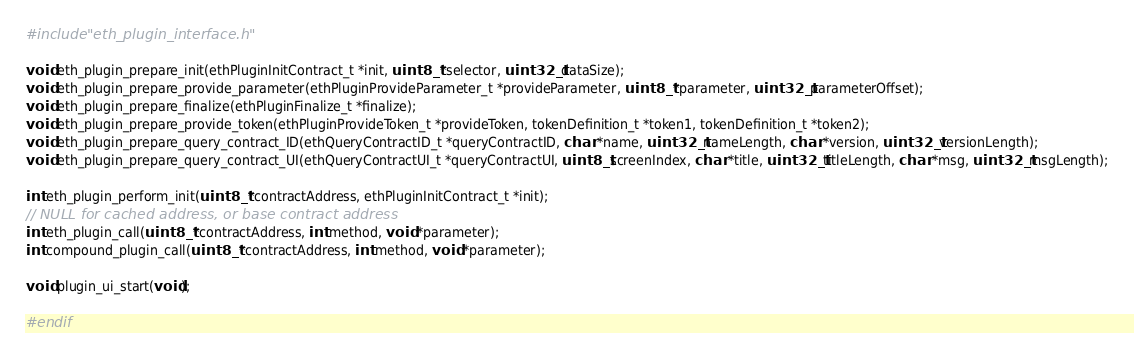<code> <loc_0><loc_0><loc_500><loc_500><_C_>#include "eth_plugin_interface.h"

void eth_plugin_prepare_init(ethPluginInitContract_t *init, uint8_t *selector, uint32_t dataSize);
void eth_plugin_prepare_provide_parameter(ethPluginProvideParameter_t *provideParameter, uint8_t *parameter, uint32_t parameterOffset);
void eth_plugin_prepare_finalize(ethPluginFinalize_t *finalize);
void eth_plugin_prepare_provide_token(ethPluginProvideToken_t *provideToken, tokenDefinition_t *token1, tokenDefinition_t *token2);
void eth_plugin_prepare_query_contract_ID(ethQueryContractID_t *queryContractID, char *name, uint32_t nameLength, char *version, uint32_t versionLength);
void eth_plugin_prepare_query_contract_UI(ethQueryContractUI_t *queryContractUI, uint8_t screenIndex, char *title, uint32_t titleLength, char *msg, uint32_t msgLength);

int eth_plugin_perform_init(uint8_t *contractAddress, ethPluginInitContract_t *init);
// NULL for cached address, or base contract address
int eth_plugin_call(uint8_t *contractAddress, int method, void *parameter);
int compound_plugin_call(uint8_t *contractAddress, int method, void *parameter);

void plugin_ui_start(void);

#endif

</code> 